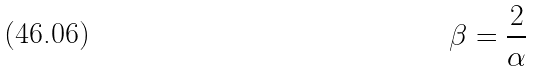<formula> <loc_0><loc_0><loc_500><loc_500>\beta = \frac { 2 } { \alpha }</formula> 